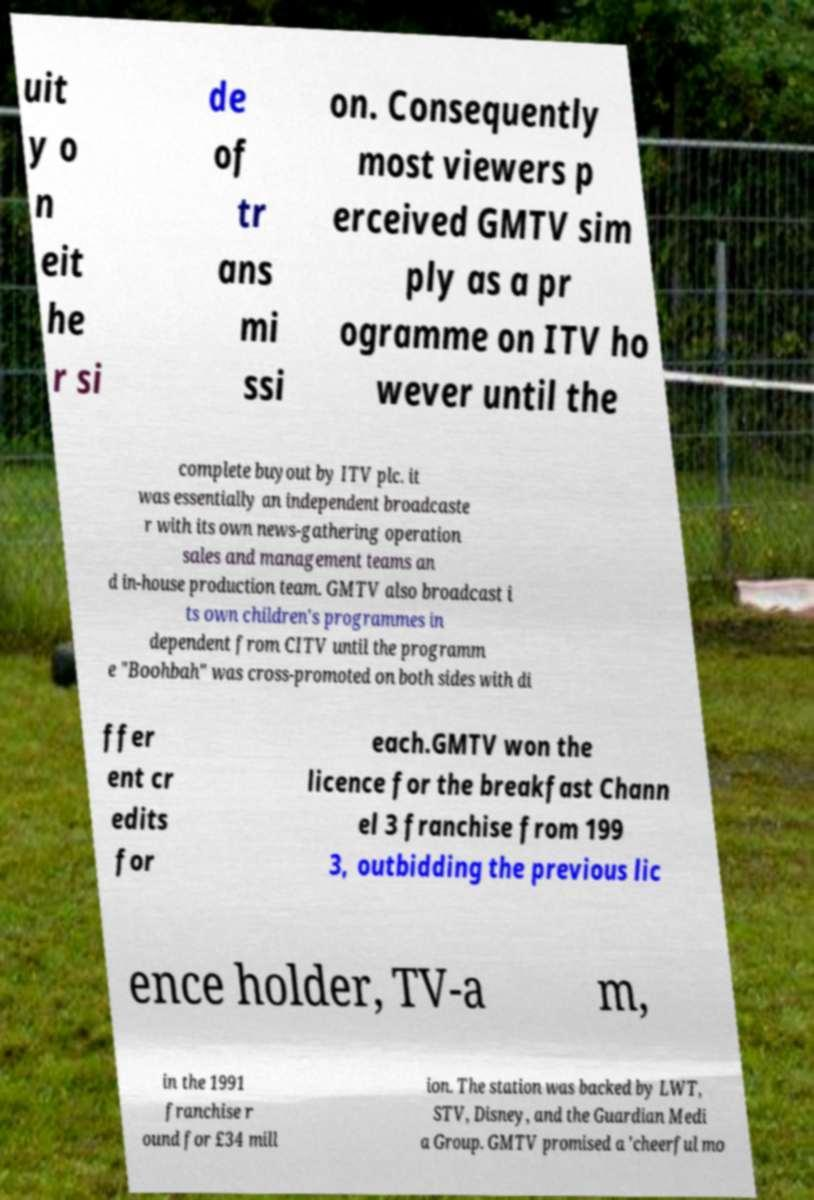Can you read and provide the text displayed in the image?This photo seems to have some interesting text. Can you extract and type it out for me? uit y o n eit he r si de of tr ans mi ssi on. Consequently most viewers p erceived GMTV sim ply as a pr ogramme on ITV ho wever until the complete buyout by ITV plc. it was essentially an independent broadcaste r with its own news-gathering operation sales and management teams an d in-house production team. GMTV also broadcast i ts own children's programmes in dependent from CITV until the programm e "Boohbah" was cross-promoted on both sides with di ffer ent cr edits for each.GMTV won the licence for the breakfast Chann el 3 franchise from 199 3, outbidding the previous lic ence holder, TV-a m, in the 1991 franchise r ound for £34 mill ion. The station was backed by LWT, STV, Disney, and the Guardian Medi a Group. GMTV promised a 'cheerful mo 